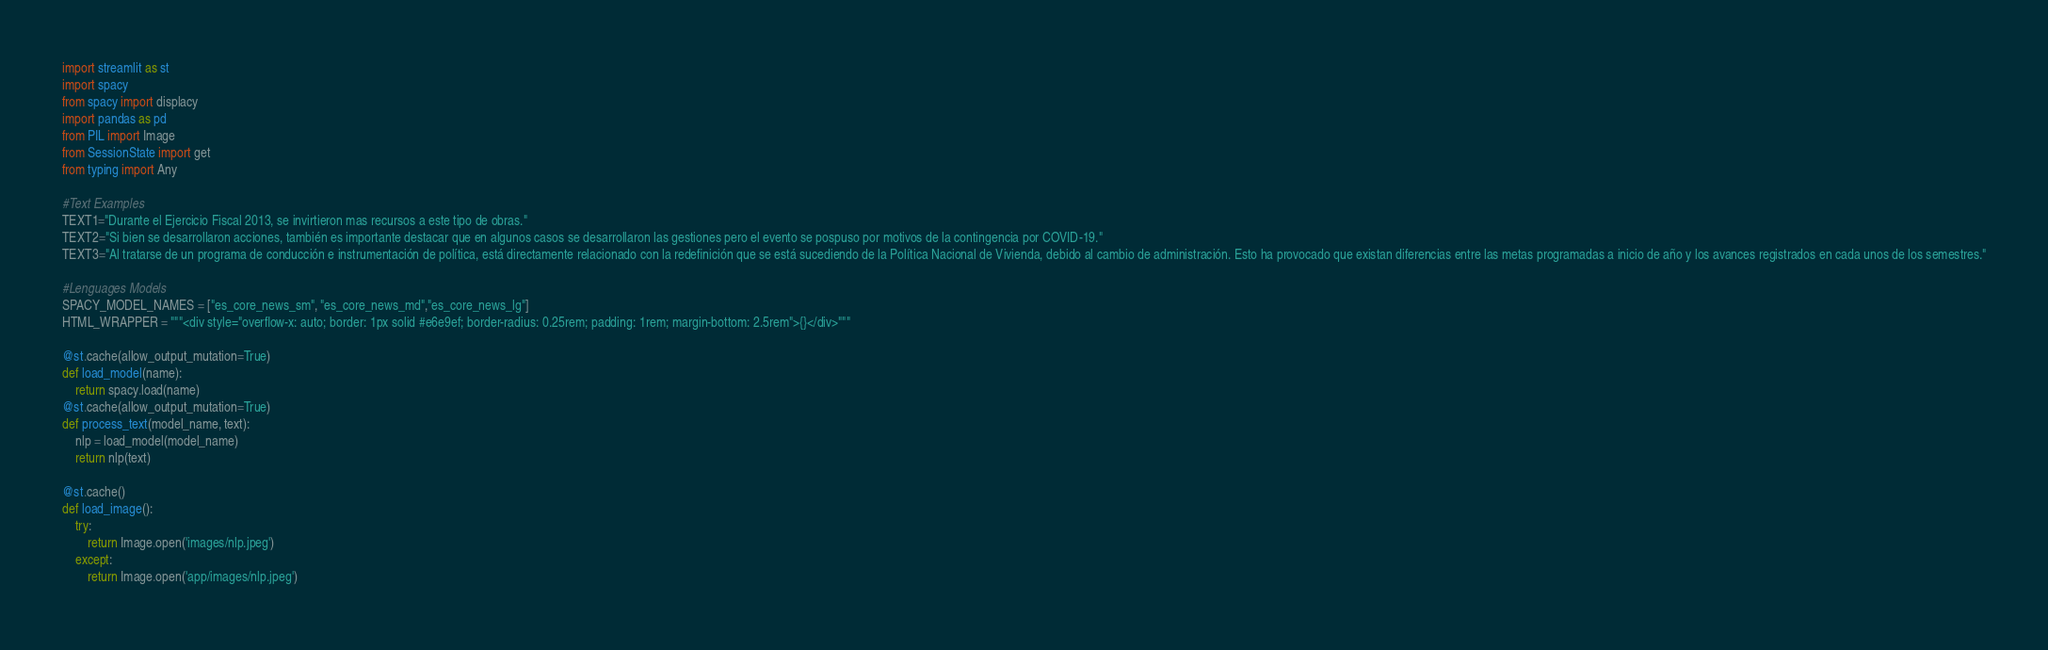Convert code to text. <code><loc_0><loc_0><loc_500><loc_500><_Python_>import streamlit as st
import spacy
from spacy import displacy
import pandas as pd
from PIL import Image
from SessionState import get
from typing import Any

#Text Examples
TEXT1="Durante el Ejercicio Fiscal 2013, se invirtieron mas recursos a este tipo de obras."
TEXT2="Si bien se desarrollaron acciones, también es importante destacar que en algunos casos se desarrollaron las gestiones pero el evento se pospuso por motivos de la contingencia por COVID-19."
TEXT3="Al tratarse de un programa de conducción e instrumentación de política, está directamente relacionado con la redefinición que se está sucediendo de la Política Nacional de Vivienda, debido al cambio de administración. Esto ha provocado que existan diferencias entre las metas programadas a inicio de año y los avances registrados en cada unos de los semestres."

#Lenguages Models
SPACY_MODEL_NAMES = ["es_core_news_sm", "es_core_news_md","es_core_news_lg"]
HTML_WRAPPER = """<div style="overflow-x: auto; border: 1px solid #e6e9ef; border-radius: 0.25rem; padding: 1rem; margin-bottom: 2.5rem">{}</div>"""

@st.cache(allow_output_mutation=True)
def load_model(name):
    return spacy.load(name)
@st.cache(allow_output_mutation=True)
def process_text(model_name, text):
    nlp = load_model(model_name)
    return nlp(text)

@st.cache()
def load_image():
    try:
        return Image.open('images/nlp.jpeg')
    except:
        return Image.open('app/images/nlp.jpeg')


</code> 